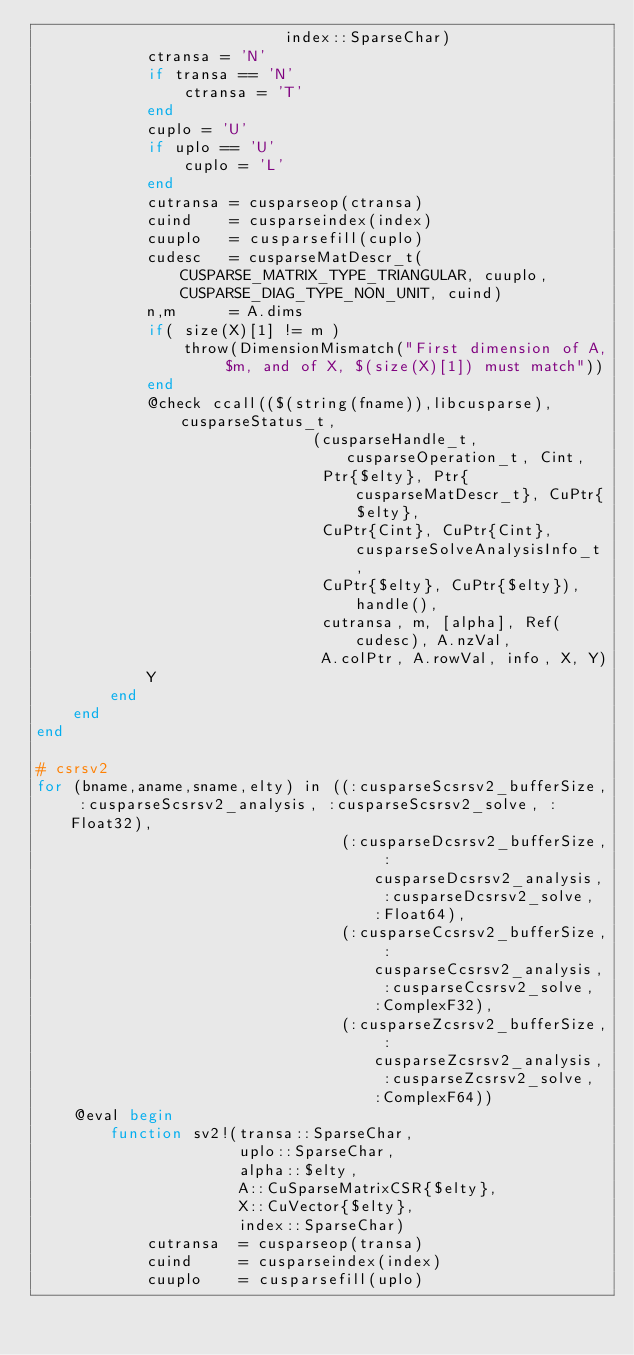<code> <loc_0><loc_0><loc_500><loc_500><_Julia_>                           index::SparseChar)
            ctransa = 'N'
            if transa == 'N'
                ctransa = 'T'
            end
            cuplo = 'U'
            if uplo == 'U'
                cuplo = 'L'
            end
            cutransa = cusparseop(ctransa)
            cuind    = cusparseindex(index)
            cuuplo   = cusparsefill(cuplo)
            cudesc   = cusparseMatDescr_t(CUSPARSE_MATRIX_TYPE_TRIANGULAR, cuuplo, CUSPARSE_DIAG_TYPE_NON_UNIT, cuind)
            n,m      = A.dims
            if( size(X)[1] != m )
                throw(DimensionMismatch("First dimension of A, $m, and of X, $(size(X)[1]) must match"))
            end
            @check ccall(($(string(fname)),libcusparse), cusparseStatus_t,
                              (cusparseHandle_t, cusparseOperation_t, Cint,
                               Ptr{$elty}, Ptr{cusparseMatDescr_t}, CuPtr{$elty},
                               CuPtr{Cint}, CuPtr{Cint}, cusparseSolveAnalysisInfo_t,
                               CuPtr{$elty}, CuPtr{$elty}), handle(),
                               cutransa, m, [alpha], Ref(cudesc), A.nzVal,
                               A.colPtr, A.rowVal, info, X, Y)
            Y
        end
    end
end

# csrsv2
for (bname,aname,sname,elty) in ((:cusparseScsrsv2_bufferSize, :cusparseScsrsv2_analysis, :cusparseScsrsv2_solve, :Float32),
                                 (:cusparseDcsrsv2_bufferSize, :cusparseDcsrsv2_analysis, :cusparseDcsrsv2_solve, :Float64),
                                 (:cusparseCcsrsv2_bufferSize, :cusparseCcsrsv2_analysis, :cusparseCcsrsv2_solve, :ComplexF32),
                                 (:cusparseZcsrsv2_bufferSize, :cusparseZcsrsv2_analysis, :cusparseZcsrsv2_solve, :ComplexF64))
    @eval begin
        function sv2!(transa::SparseChar,
                      uplo::SparseChar,
                      alpha::$elty,
                      A::CuSparseMatrixCSR{$elty},
                      X::CuVector{$elty},
                      index::SparseChar)
            cutransa  = cusparseop(transa)
            cuind     = cusparseindex(index)
            cuuplo    = cusparsefill(uplo)</code> 